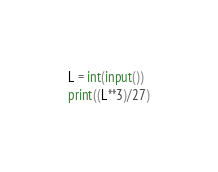<code> <loc_0><loc_0><loc_500><loc_500><_Python_>L = int(input())
print((L**3)/27)</code> 